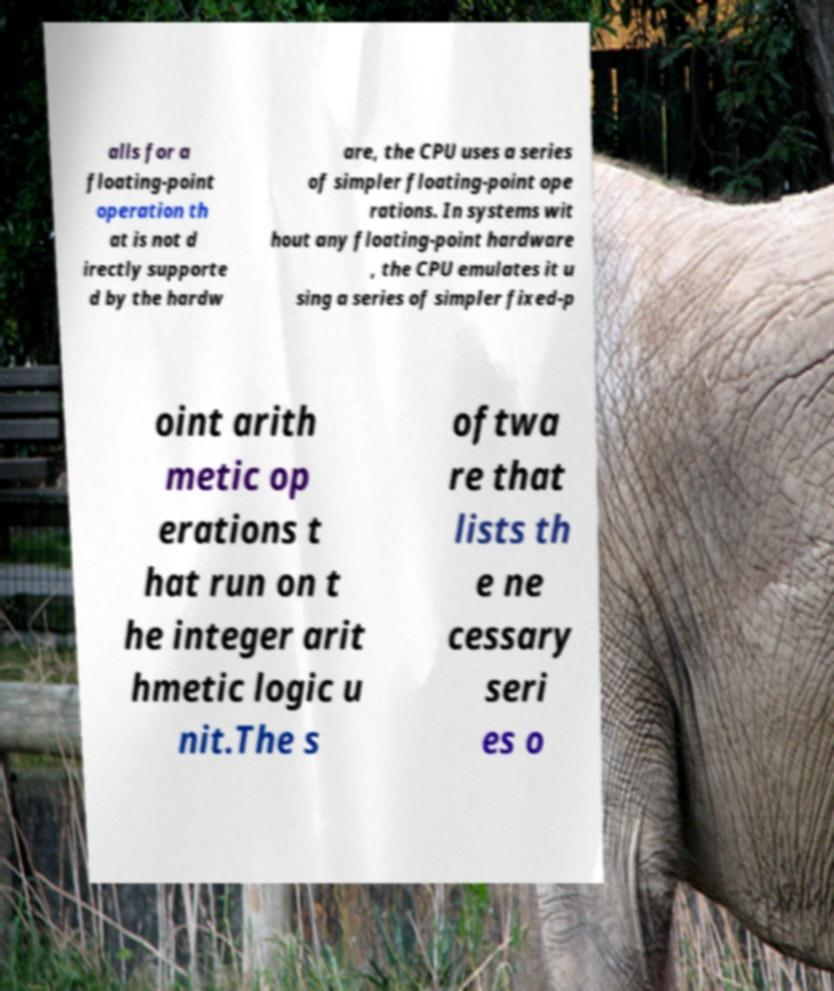For documentation purposes, I need the text within this image transcribed. Could you provide that? alls for a floating-point operation th at is not d irectly supporte d by the hardw are, the CPU uses a series of simpler floating-point ope rations. In systems wit hout any floating-point hardware , the CPU emulates it u sing a series of simpler fixed-p oint arith metic op erations t hat run on t he integer arit hmetic logic u nit.The s oftwa re that lists th e ne cessary seri es o 